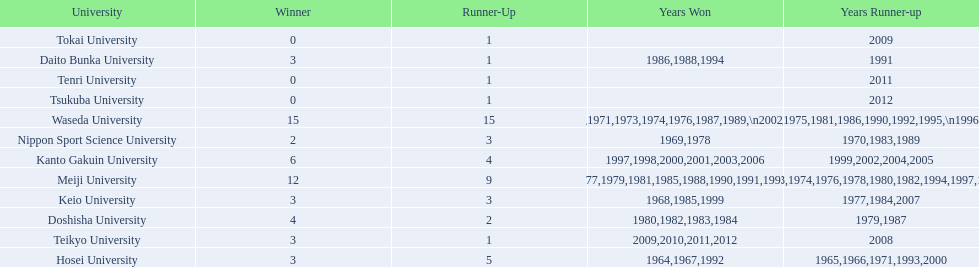Which university had 6 wins? Kanto Gakuin University. Which university had 12 wins? Meiji University. Which university had more than 12 wins? Waseda University. 